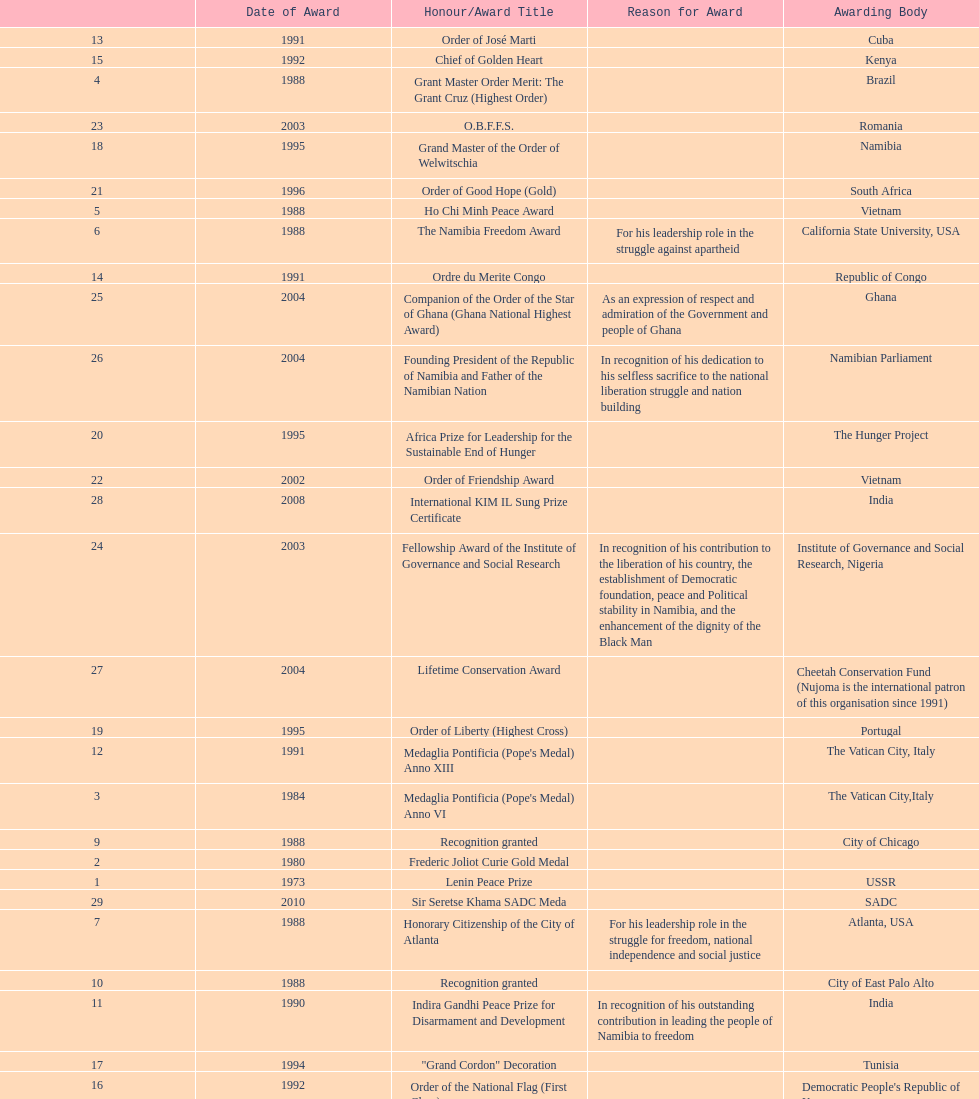What was the last award that nujoma won? Sir Seretse Khama SADC Meda. 